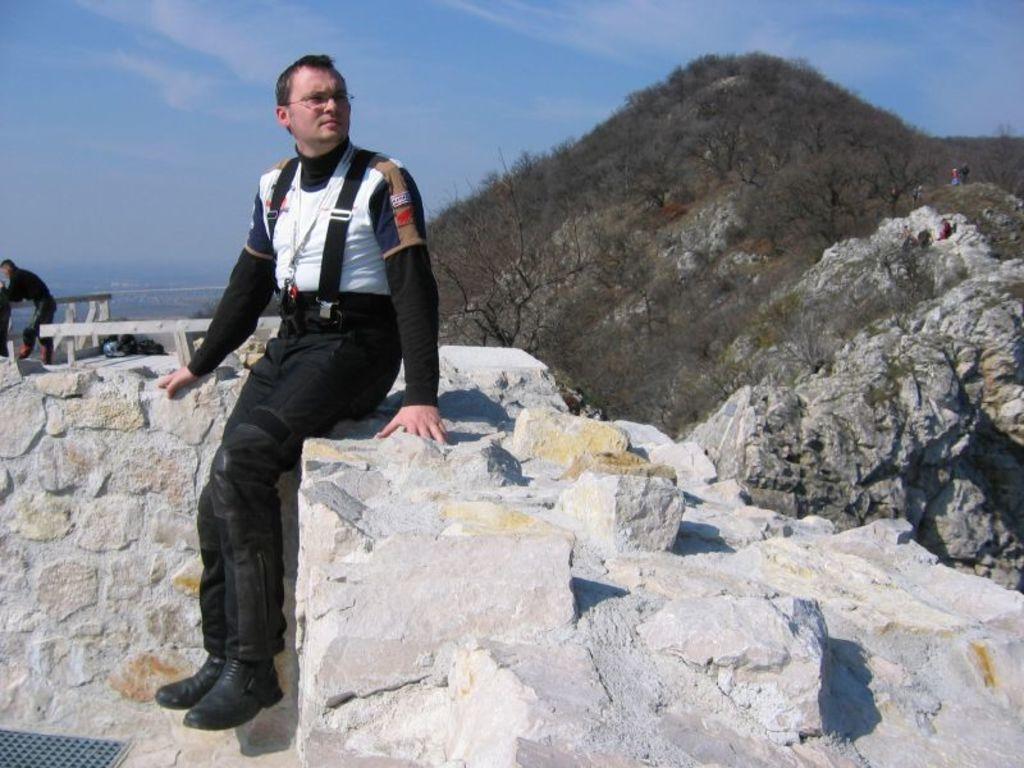How would you summarize this image in a sentence or two? Here we can see a man and he has spectacles. There are trees. Here we can see a person and a mountain. In the background there is sky. 